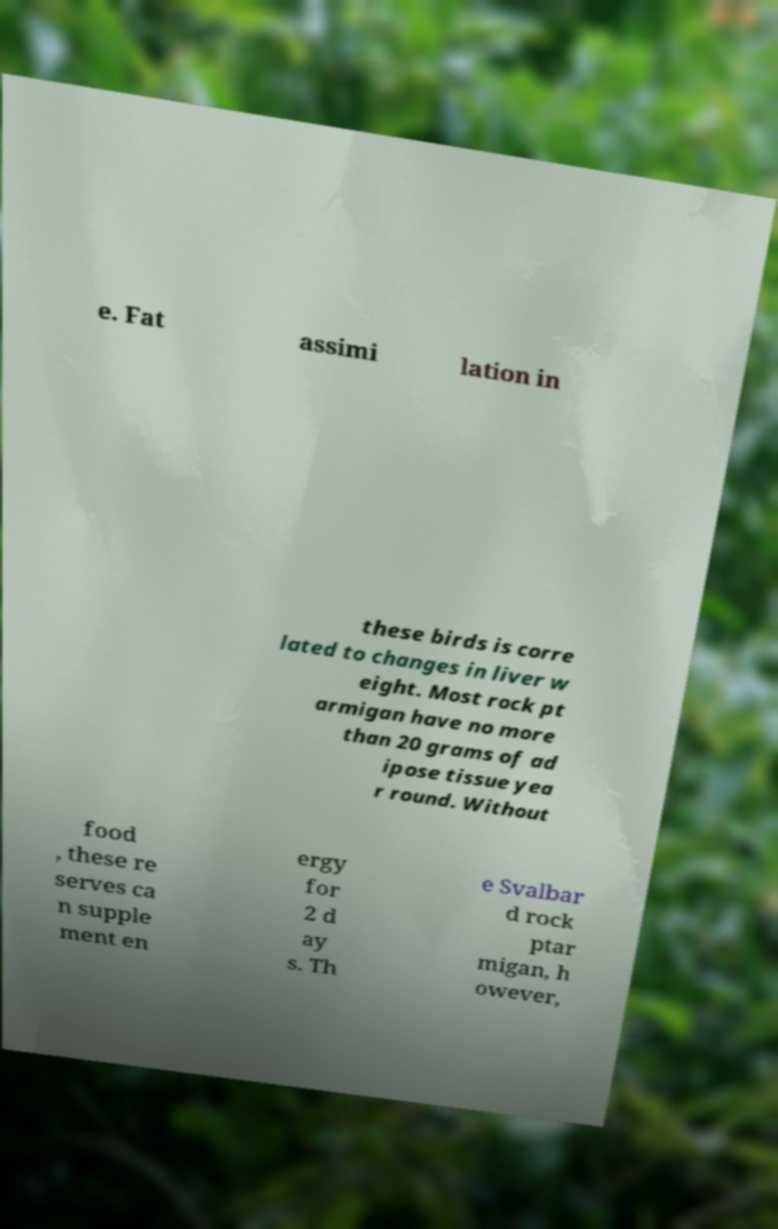What messages or text are displayed in this image? I need them in a readable, typed format. e. Fat assimi lation in these birds is corre lated to changes in liver w eight. Most rock pt armigan have no more than 20 grams of ad ipose tissue yea r round. Without food , these re serves ca n supple ment en ergy for 2 d ay s. Th e Svalbar d rock ptar migan, h owever, 